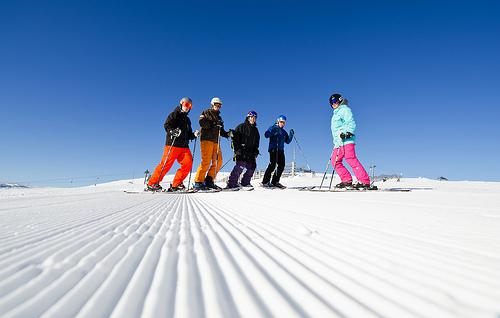Question: what are the people doing?
Choices:
A. Snowboarding.
B. Sledding.
C. Ice-skating.
D. Skiing.
Answer with the letter. Answer: D Question: how many people are there?
Choices:
A. 5.
B. 4.
C. 3.
D. 6.
Answer with the letter. Answer: A Question: what color pants is the person on the left wearing?
Choices:
A. Brown.
B. Black.
C. Orange.
D. Blue.
Answer with the letter. Answer: C Question: what color pants is the girl on the right wearing?
Choices:
A. Pink.
B. Red.
C. Orange.
D. Yellow.
Answer with the letter. Answer: A Question: when is it?
Choices:
A. Day time.
B. Nighttime.
C. Summer.
D. Midnight.
Answer with the letter. Answer: A Question: why are the dressed warmly?
Choices:
A. It is cold.
B. It is warm.
C. It is wet.
D. It is dry.
Answer with the letter. Answer: A Question: where are the people?
Choices:
A. In the desert.
B. On the slopes.
C. In the water.
D. On the ice.
Answer with the letter. Answer: B Question: who is on the right?
Choices:
A. A boy.
B. A man.
C. A girl.
D. A dog.
Answer with the letter. Answer: C 